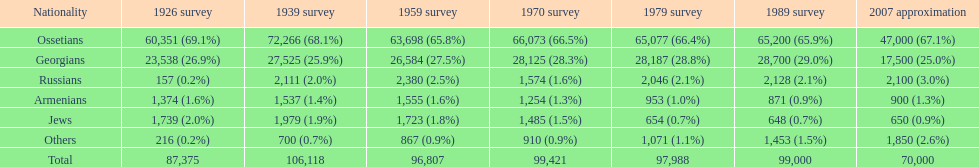How many russians lived in south ossetia in 1970? 1,574. 